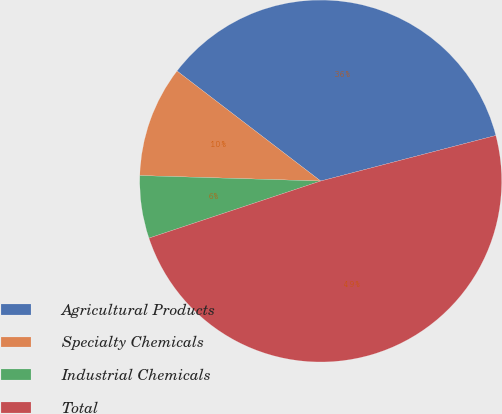<chart> <loc_0><loc_0><loc_500><loc_500><pie_chart><fcel>Agricultural Products<fcel>Specialty Chemicals<fcel>Industrial Chemicals<fcel>Total<nl><fcel>35.55%<fcel>9.92%<fcel>5.59%<fcel>48.94%<nl></chart> 